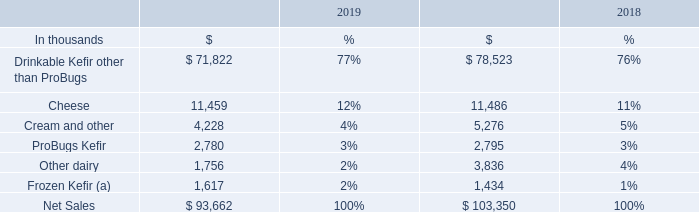PRODUCTS
Our primary product is drinkable kefir, a cultured dairy product. Lifeway Kefir is tart and tangy, high in protein, calcium and vitamin D. Thanks to our exclusive blend of kefir cultures, each cup of kefir contains 12 live and active cultures and 15 to 20 billion beneficial CFU (Colony Forming Units) at the time of manufacture.
We manufacture (directly or through co-packers) our products under our own brand, as well as under private labels on behalf of certain customers. As of December 31, 2019, Lifeway offered approximately 20 varieties of our kefir products including more than 60 flavors . In addition to our core drinkable kefir products, we offer several lines of products developed through our innovation and development efforts. These include Kefir Cups, a strained, cupped version of our kefir; and Organic Farmer Cheese Cups, a cupped version of our soft cheeses, both served in resealable 5 oz. containers. We also offer Skyr, a strained cupped Icelandic yogurt; Plantiful, a plant-based probiotic beverage made from organic and non-GMO pea protein with 10 vegan kefir cultures; a line of probiotic supplements for adults and children; and a soft serve kefir mix.
Our product categories are:
• Drinkable Kefir, sold in a variety of organic and non-organic sizes, flavors, and types, including low fat, non-fat, whole milk, protein, and BioKefir (a 3.5 oz. kefir with additional probiotic cultures). • European-style soft cheeses, including farmer cheese in resealable cups. • Cream and other, which consists primarily of cream, a byproduct of making our kefir. • ProBugs, a line of kefir products designed for children. • Other Dairy, which includes Cupped Kefir and Icelandic Skyr, a line of strained kefir and yogurt products in resealable cups. • Frozen Kefir, available in both soft serve and pint-size containers.
Net sales of products by category were as follows for the years ended December 31:
(a) Includes Lifeway Kefir Shop sales
What is the percentage of net sales from Cheese in 2018 and 2019 respectively? 11%, 12%. What is the amount of net sales from ProBugs Kelir in 2018 and 2019 respectively?
Answer scale should be: thousand. 2,795, 2,780. What does the table show? Net sales of products by category were as follows for the years ended december 31. What is the difference in net sales between drinkable Kefir other than ProBugs and Cheese in 2019?
Answer scale should be: thousand. 71,822-11,459
Answer: 60363. What is the average total net sales for both 2018 and 2019?
Answer scale should be: thousand. (93,662+103,350)/2
Answer: 98506. What is the percentage constitution of net sales from Frozen Kefir among the total net sales in 2019?
Answer scale should be: percent. 1,617/93,662
Answer: 1.73. 